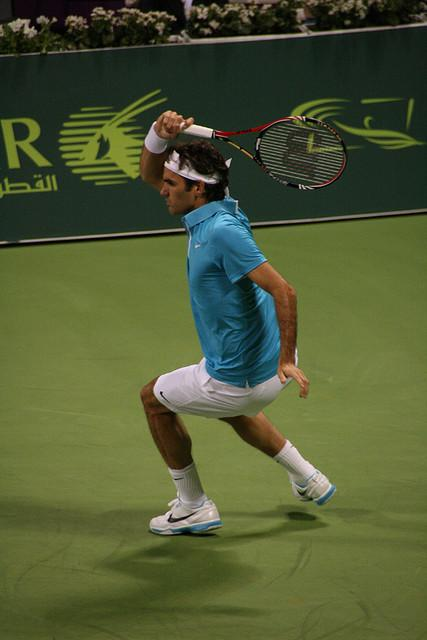What is the athletes last name?

Choices:
A) garrett
B) jackson
C) federer
D) jones federer 